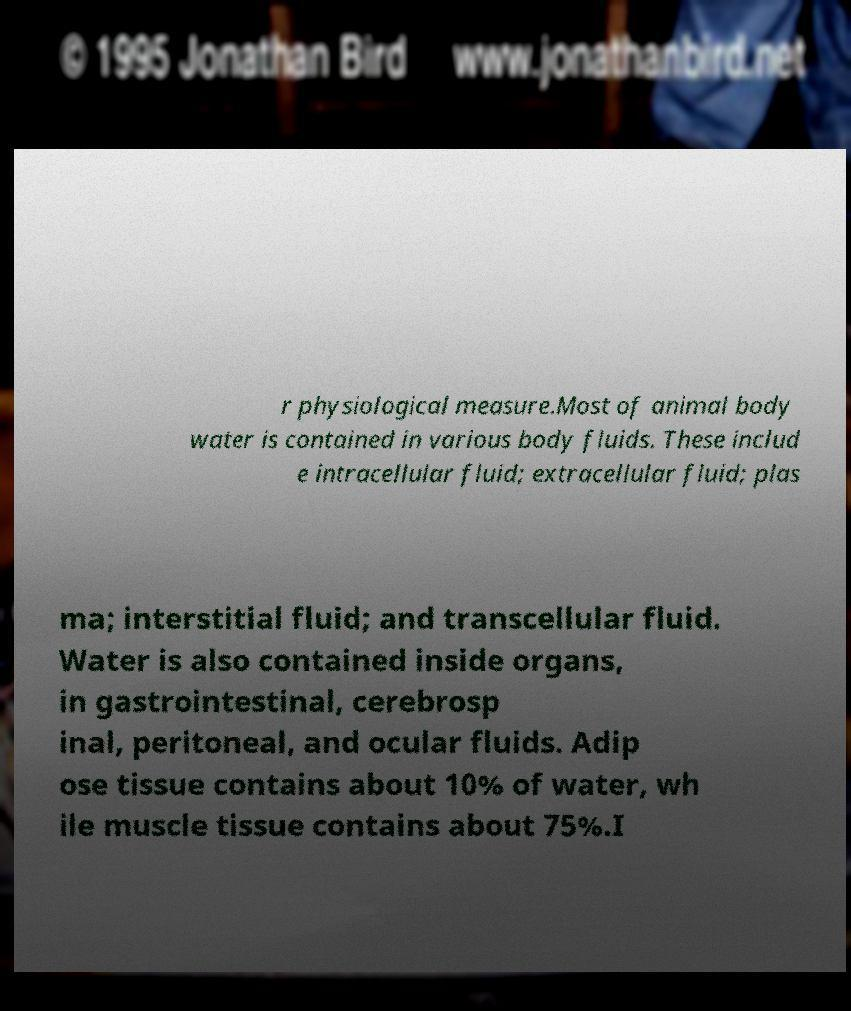Could you extract and type out the text from this image? r physiological measure.Most of animal body water is contained in various body fluids. These includ e intracellular fluid; extracellular fluid; plas ma; interstitial fluid; and transcellular fluid. Water is also contained inside organs, in gastrointestinal, cerebrosp inal, peritoneal, and ocular fluids. Adip ose tissue contains about 10% of water, wh ile muscle tissue contains about 75%.I 